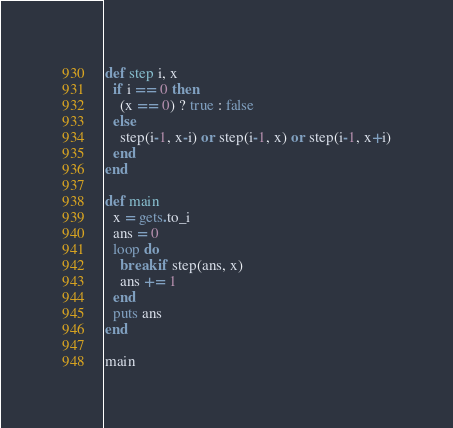<code> <loc_0><loc_0><loc_500><loc_500><_Ruby_>def step i, x
  if i == 0 then
    (x == 0) ? true : false
  else
    step(i-1, x-i) or step(i-1, x) or step(i-1, x+i)
  end
end

def main
  x = gets.to_i
  ans = 0
  loop do
    break if step(ans, x)
    ans += 1
  end
  puts ans
end

main
</code> 